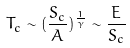<formula> <loc_0><loc_0><loc_500><loc_500>T _ { c } \sim ( \frac { S _ { c } } { A } ) ^ { \frac { 1 } { \gamma } } \sim \frac { E } { S _ { c } }</formula> 